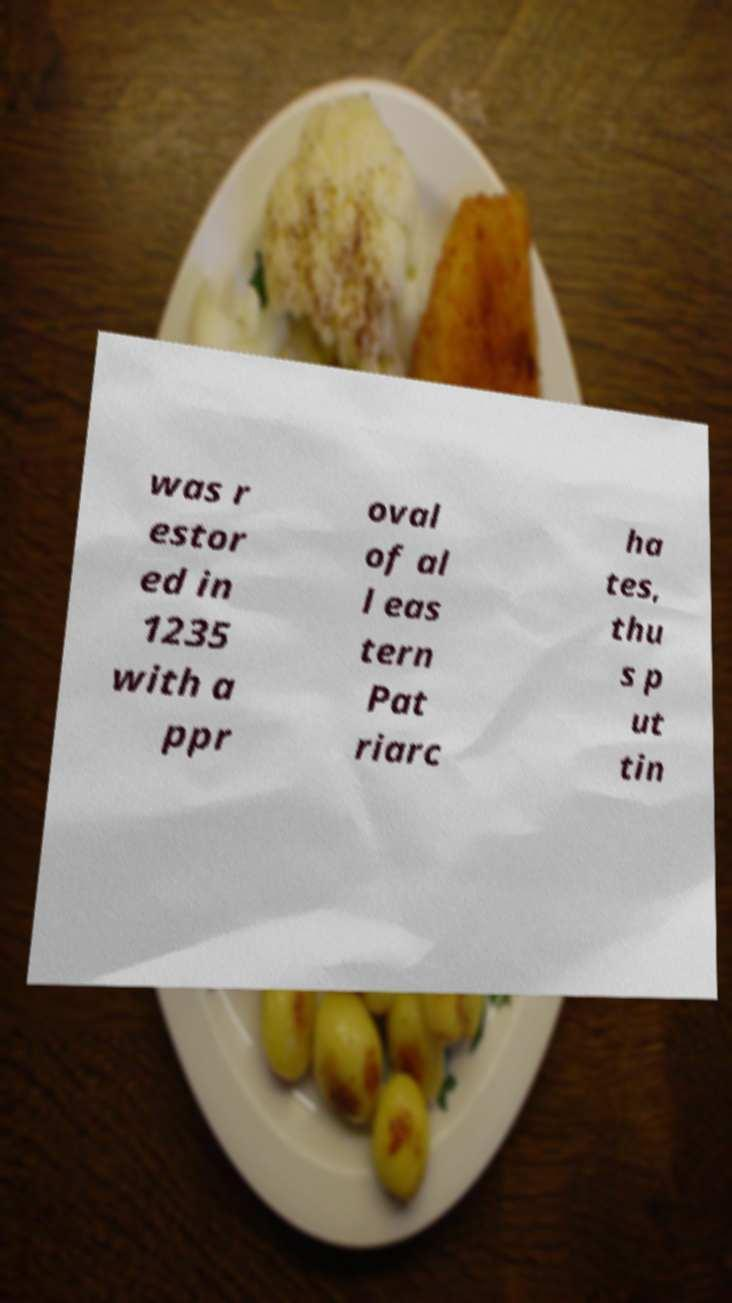There's text embedded in this image that I need extracted. Can you transcribe it verbatim? was r estor ed in 1235 with a ppr oval of al l eas tern Pat riarc ha tes, thu s p ut tin 